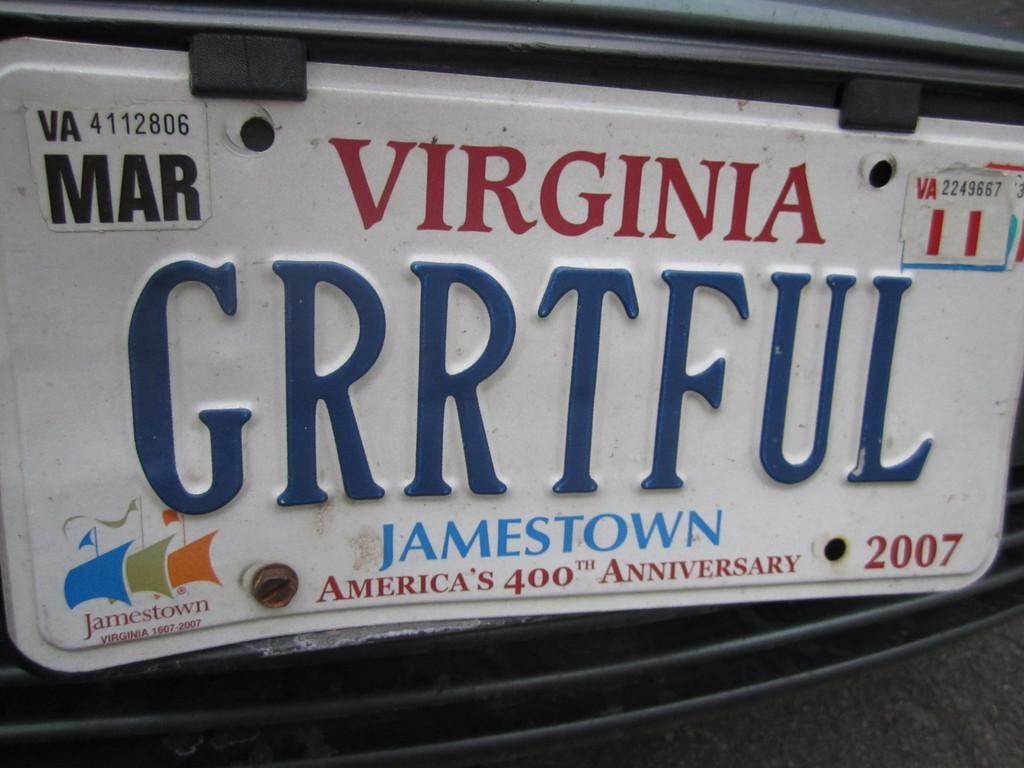Provide a one-sentence caption for the provided image. The Virginia license plate is a special one for America's 400th Anniversary at Jamestown. 